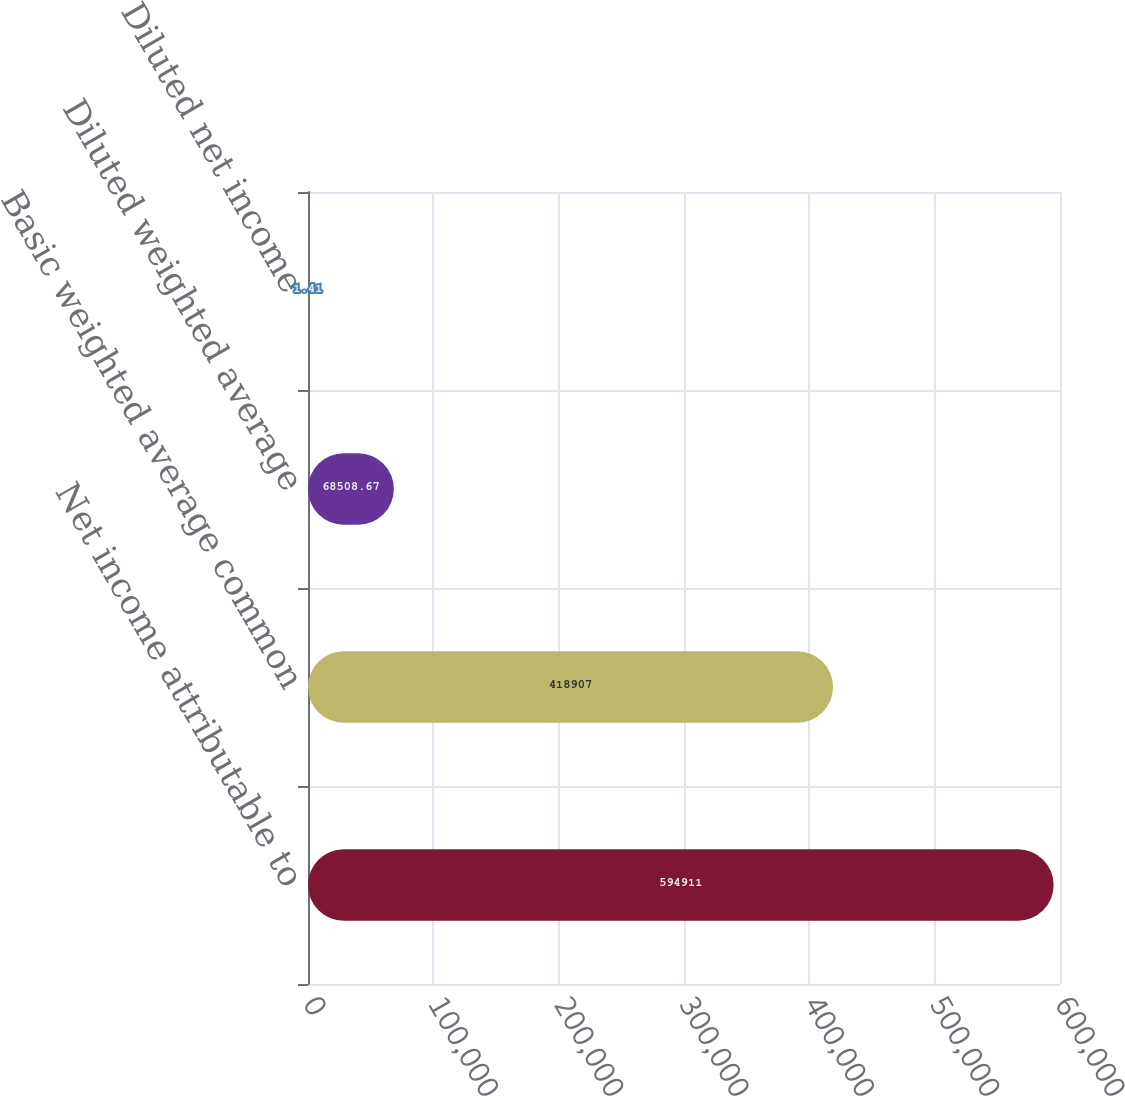Convert chart to OTSL. <chart><loc_0><loc_0><loc_500><loc_500><bar_chart><fcel>Net income attributable to<fcel>Basic weighted average common<fcel>Diluted weighted average<fcel>Diluted net income<nl><fcel>594911<fcel>418907<fcel>68508.7<fcel>1.41<nl></chart> 